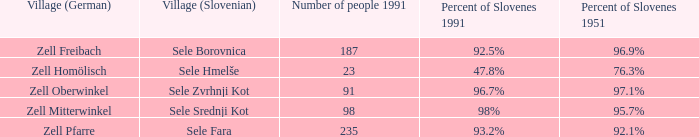Give me the minimum number of people in 1991 with 92.5% of Slovenes in 1991. 187.0. 